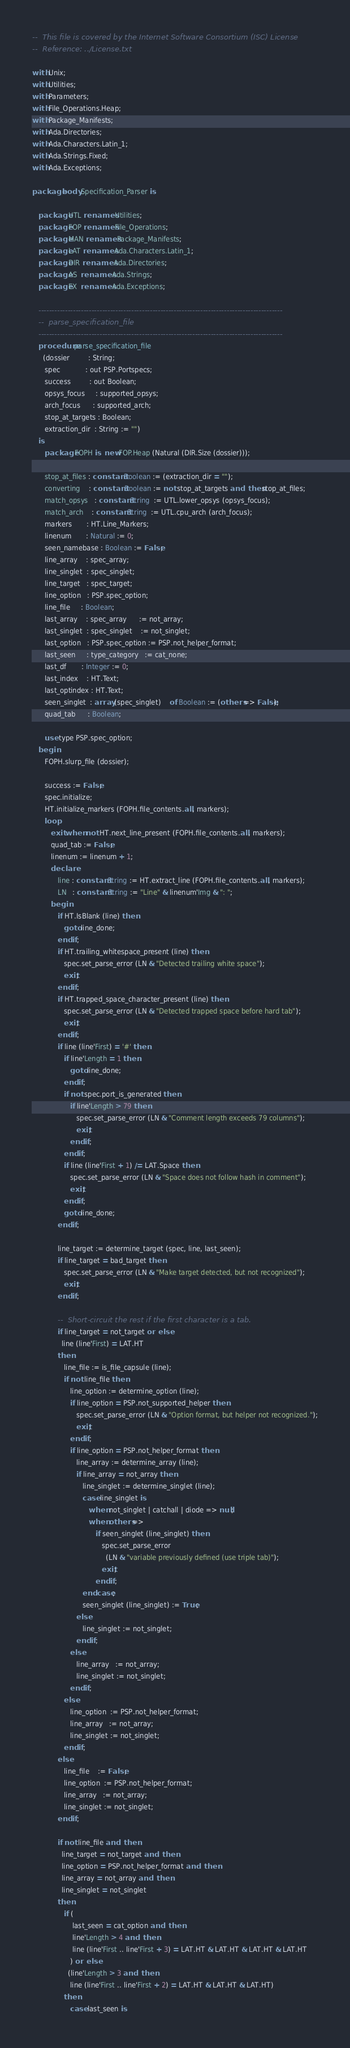Convert code to text. <code><loc_0><loc_0><loc_500><loc_500><_Ada_>--  This file is covered by the Internet Software Consortium (ISC) License
--  Reference: ../License.txt

with Unix;
with Utilities;
with Parameters;
with File_Operations.Heap;
with Package_Manifests;
with Ada.Directories;
with Ada.Characters.Latin_1;
with Ada.Strings.Fixed;
with Ada.Exceptions;

package body Specification_Parser is

   package UTL renames Utilities;
   package FOP renames File_Operations;
   package MAN renames Package_Manifests;
   package LAT renames Ada.Characters.Latin_1;
   package DIR renames Ada.Directories;
   package AS  renames Ada.Strings;
   package EX  renames Ada.Exceptions;

   --------------------------------------------------------------------------------------------
   --  parse_specification_file
   --------------------------------------------------------------------------------------------
   procedure parse_specification_file
     (dossier         : String;
      spec            : out PSP.Portspecs;
      success         : out Boolean;
      opsys_focus     : supported_opsys;
      arch_focus      : supported_arch;
      stop_at_targets : Boolean;
      extraction_dir  : String := "")
   is
      package FOPH is new FOP.Heap (Natural (DIR.Size (dossier)));

      stop_at_files : constant Boolean := (extraction_dir = "");
      converting    : constant Boolean := not stop_at_targets and then stop_at_files;
      match_opsys   : constant String  := UTL.lower_opsys (opsys_focus);
      match_arch    : constant String  := UTL.cpu_arch (arch_focus);
      markers       : HT.Line_Markers;
      linenum       : Natural := 0;
      seen_namebase : Boolean := False;
      line_array    : spec_array;
      line_singlet  : spec_singlet;
      line_target   : spec_target;
      line_option   : PSP.spec_option;
      line_file     : Boolean;
      last_array    : spec_array      := not_array;
      last_singlet  : spec_singlet    := not_singlet;
      last_option   : PSP.spec_option := PSP.not_helper_format;
      last_seen     : type_category   := cat_none;
      last_df       : Integer := 0;
      last_index    : HT.Text;
      last_optindex : HT.Text;
      seen_singlet  : array (spec_singlet)    of Boolean := (others => False);
      quad_tab      : Boolean;

      use type PSP.spec_option;
   begin
      FOPH.slurp_file (dossier);

      success := False;
      spec.initialize;
      HT.initialize_markers (FOPH.file_contents.all, markers);
      loop
         exit when not HT.next_line_present (FOPH.file_contents.all, markers);
         quad_tab := False;
         linenum := linenum + 1;
         declare
            line : constant String := HT.extract_line (FOPH.file_contents.all, markers);
            LN   : constant String := "Line" & linenum'Img & ": ";
         begin
            if HT.IsBlank (line) then
               goto line_done;
            end if;
            if HT.trailing_whitespace_present (line) then
               spec.set_parse_error (LN & "Detected trailing white space");
               exit;
            end if;
            if HT.trapped_space_character_present (line) then
               spec.set_parse_error (LN & "Detected trapped space before hard tab");
               exit;
            end if;
            if line (line'First) = '#' then
               if line'Length = 1 then
                  goto line_done;
               end if;
               if not spec.port_is_generated then
                  if line'Length > 79 then
                     spec.set_parse_error (LN & "Comment length exceeds 79 columns");
                     exit;
                  end if;
               end if;
               if line (line'First + 1) /= LAT.Space then
                  spec.set_parse_error (LN & "Space does not follow hash in comment");
                  exit;
               end if;
               goto line_done;
            end if;

            line_target := determine_target (spec, line, last_seen);
            if line_target = bad_target then
               spec.set_parse_error (LN & "Make target detected, but not recognized");
               exit;
            end if;

            --  Short-circuit the rest if the first character is a tab.
            if line_target = not_target or else
              line (line'First) = LAT.HT
            then
               line_file := is_file_capsule (line);
               if not line_file then
                  line_option := determine_option (line);
                  if line_option = PSP.not_supported_helper then
                     spec.set_parse_error (LN & "Option format, but helper not recognized.");
                     exit;
                  end if;
                  if line_option = PSP.not_helper_format then
                     line_array := determine_array (line);
                     if line_array = not_array then
                        line_singlet := determine_singlet (line);
                        case line_singlet is
                           when not_singlet | catchall | diode => null;
                           when others =>
                              if seen_singlet (line_singlet) then
                                 spec.set_parse_error
                                   (LN & "variable previously defined (use triple tab)");
                                 exit;
                              end if;
                        end case;
                        seen_singlet (line_singlet) := True;
                     else
                        line_singlet := not_singlet;
                     end if;
                  else
                     line_array   := not_array;
                     line_singlet := not_singlet;
                  end if;
               else
                  line_option  := PSP.not_helper_format;
                  line_array   := not_array;
                  line_singlet := not_singlet;
               end if;
            else
               line_file    := False;
               line_option  := PSP.not_helper_format;
               line_array   := not_array;
               line_singlet := not_singlet;
            end if;

            if not line_file and then
              line_target = not_target and then
              line_option = PSP.not_helper_format and then
              line_array = not_array and then
              line_singlet = not_singlet
            then
               if (
                   last_seen = cat_option and then
                   line'Length > 4 and then
                   line (line'First .. line'First + 3) = LAT.HT & LAT.HT & LAT.HT & LAT.HT
                  ) or else
                 (line'Length > 3 and then
                  line (line'First .. line'First + 2) = LAT.HT & LAT.HT & LAT.HT)
               then
                  case last_seen is</code> 